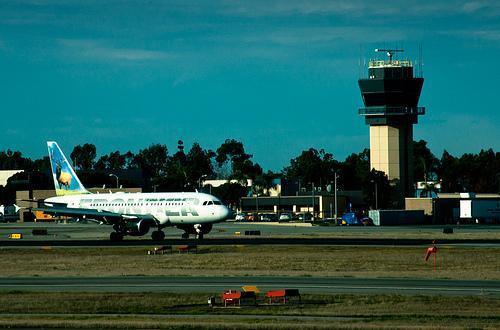How many planes are in the image?
Give a very brief answer. 1. 